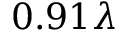Convert formula to latex. <formula><loc_0><loc_0><loc_500><loc_500>0 . 9 1 \lambda</formula> 